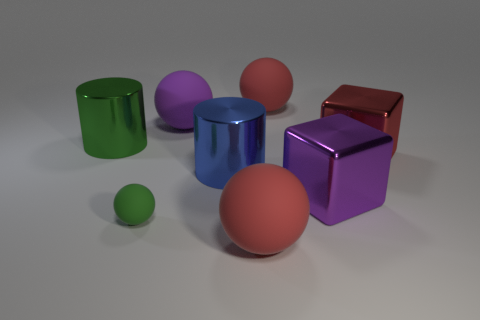Add 1 small yellow things. How many objects exist? 9 Subtract all large spheres. How many spheres are left? 1 Subtract all cylinders. How many objects are left? 6 Subtract 2 balls. How many balls are left? 2 Subtract all green spheres. How many spheres are left? 3 Subtract 2 red balls. How many objects are left? 6 Subtract all gray cylinders. Subtract all purple cubes. How many cylinders are left? 2 Subtract all blue blocks. How many red spheres are left? 2 Subtract all purple blocks. Subtract all tiny cyan matte balls. How many objects are left? 7 Add 2 big metal cubes. How many big metal cubes are left? 4 